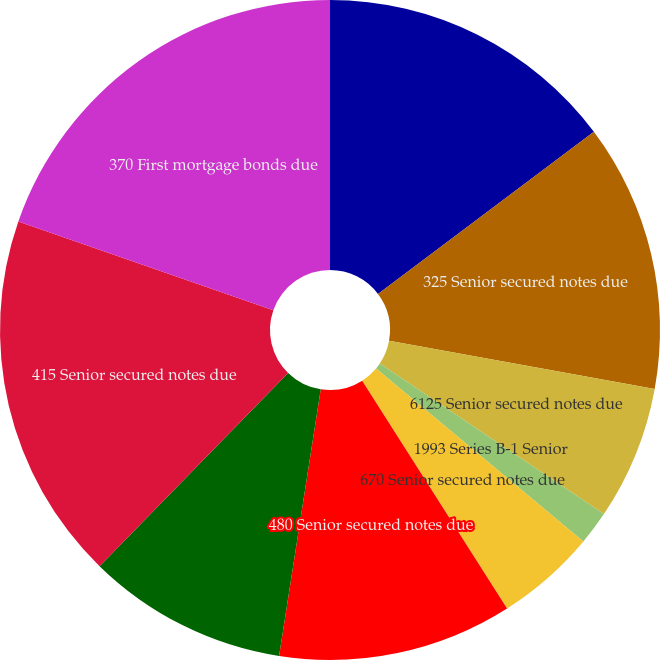Convert chart. <chart><loc_0><loc_0><loc_500><loc_500><pie_chart><fcel>270 Senior secured notes due<fcel>325 Senior secured notes due<fcel>6125 Senior secured notes due<fcel>1993 Series B-1 Senior<fcel>670 Senior secured notes due<fcel>480 Senior secured notes due<fcel>430 Senior secured notes due<fcel>415 Senior secured notes due<fcel>370 First mortgage bonds due<nl><fcel>14.75%<fcel>13.11%<fcel>6.56%<fcel>1.65%<fcel>4.92%<fcel>11.48%<fcel>9.84%<fcel>18.03%<fcel>19.67%<nl></chart> 